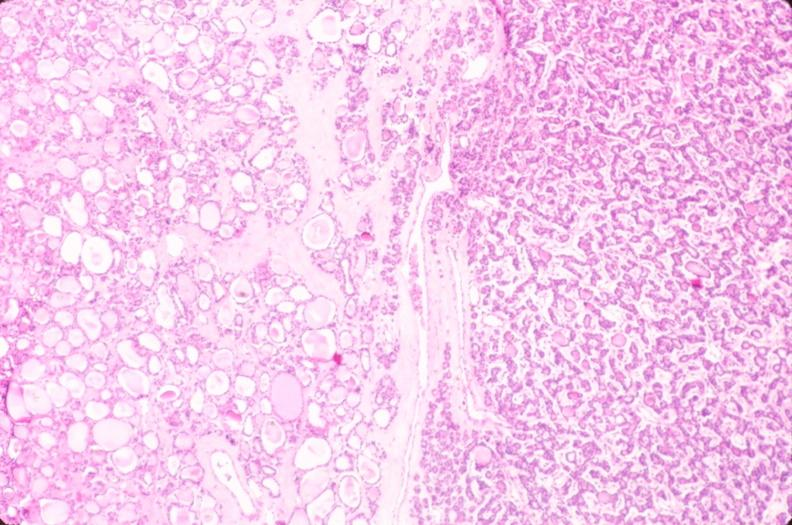what is present?
Answer the question using a single word or phrase. Endocrine 